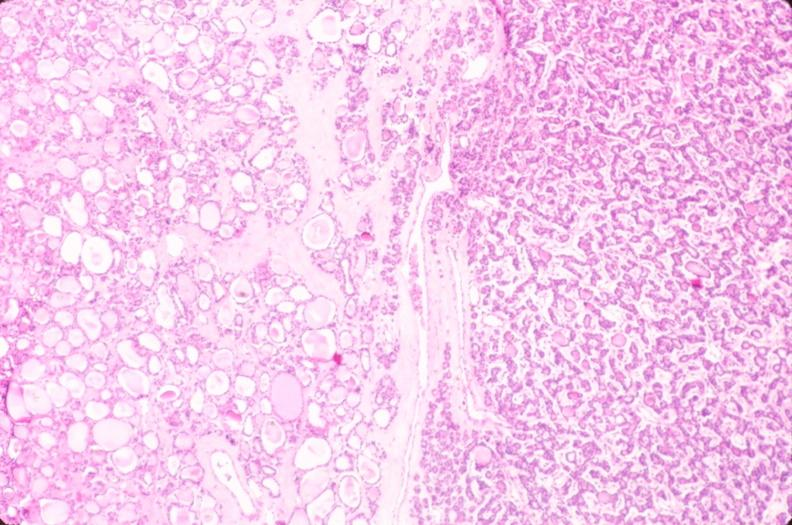what is present?
Answer the question using a single word or phrase. Endocrine 